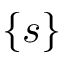Convert formula to latex. <formula><loc_0><loc_0><loc_500><loc_500>\{ s \}</formula> 